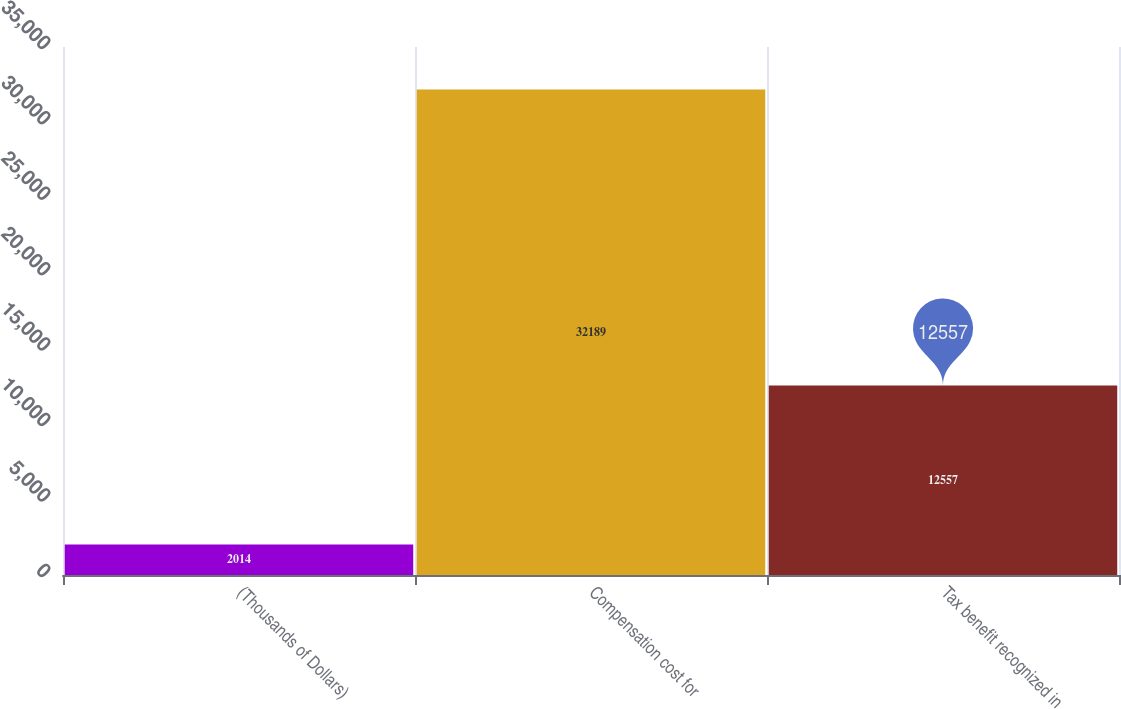<chart> <loc_0><loc_0><loc_500><loc_500><bar_chart><fcel>(Thousands of Dollars)<fcel>Compensation cost for<fcel>Tax benefit recognized in<nl><fcel>2014<fcel>32189<fcel>12557<nl></chart> 